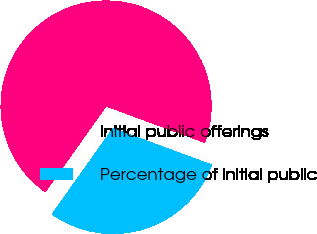Convert chart to OTSL. <chart><loc_0><loc_0><loc_500><loc_500><pie_chart><fcel>Initial public offerings<fcel>Percentage of initial public<nl><fcel>70.81%<fcel>29.19%<nl></chart> 